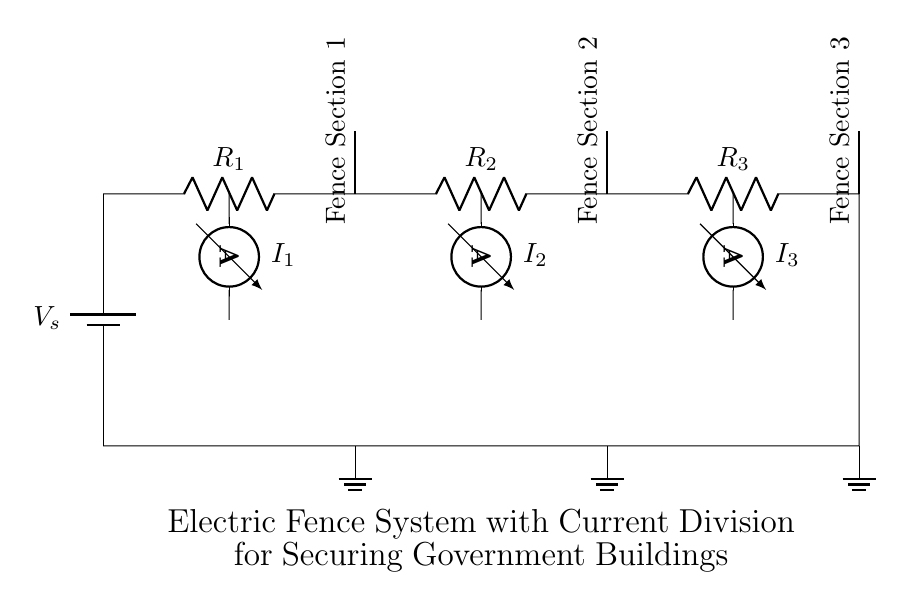What is the main power supply in this circuit? The main power supply is a battery, shown at the beginning of the circuit as V_s.
Answer: battery How many resistors are present in this circuit? There are three resistors connected in series between the battery and the ground, labelled as R_1, R_2, and R_3.
Answer: three What does each section of the fence represent in this diagram? Each section of the fence corresponds to a measurement point where current is detected, specifically Fence Section 1, Fence Section 2, and Fence Section 3, placed above each resistor.
Answer: fence sections What is the current measurement at Fence Section 2? The current measurement at Fence Section 2 corresponds to I_2, which is the ammeter connected at the junction of R_2.
Answer: I_2 How does the total current divide among the resistors in this circuit? The total current from the battery is divided among the three resistors R_1, R_2, and R_3 according to the resistance values; the total current will distribute inversely proportional to their resistances.
Answer: according to resistance values What type of current division is utilized in this electric fence system? This system employs a parallel current divider configuration, though it appears in a series format because the resistors are aligned individually representing branches.
Answer: current divider What would happen if one of the fence sections were to short circuit? If one of the sections were to short circuit, it would significantly reduce the total resistance in that branch, thereby increasing the current in the remaining branches and potentially causing an overload.
Answer: increased current in remaining branches 